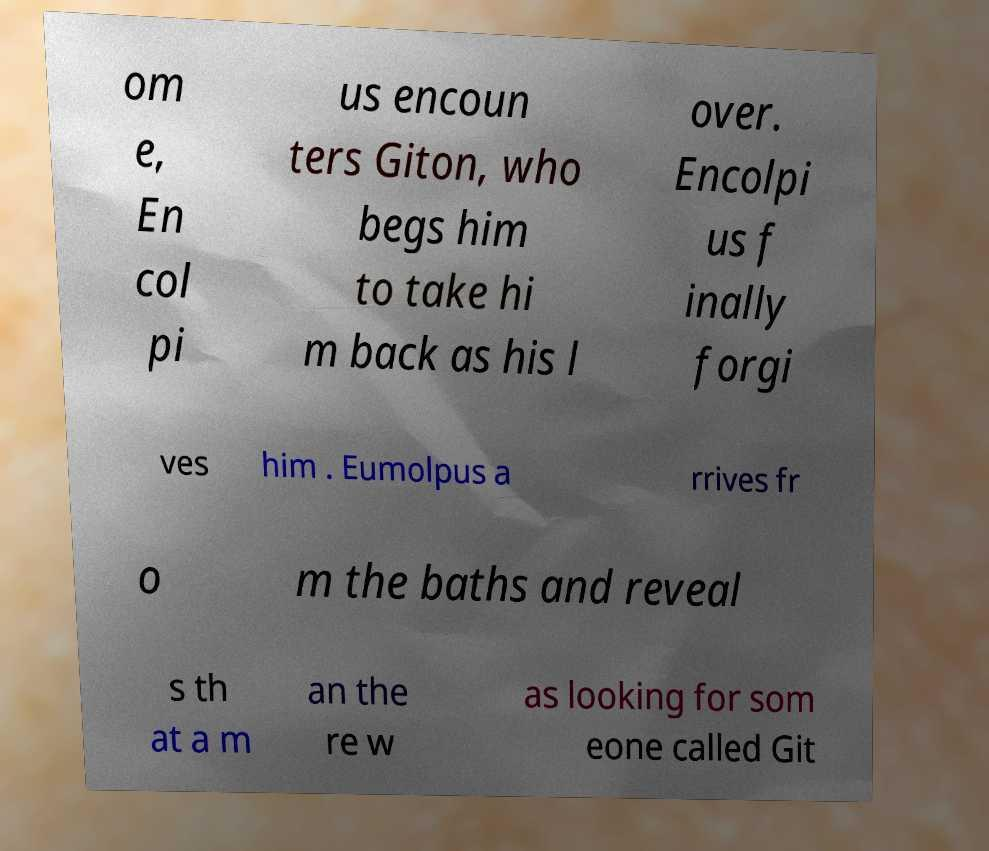Please read and relay the text visible in this image. What does it say? om e, En col pi us encoun ters Giton, who begs him to take hi m back as his l over. Encolpi us f inally forgi ves him . Eumolpus a rrives fr o m the baths and reveal s th at a m an the re w as looking for som eone called Git 